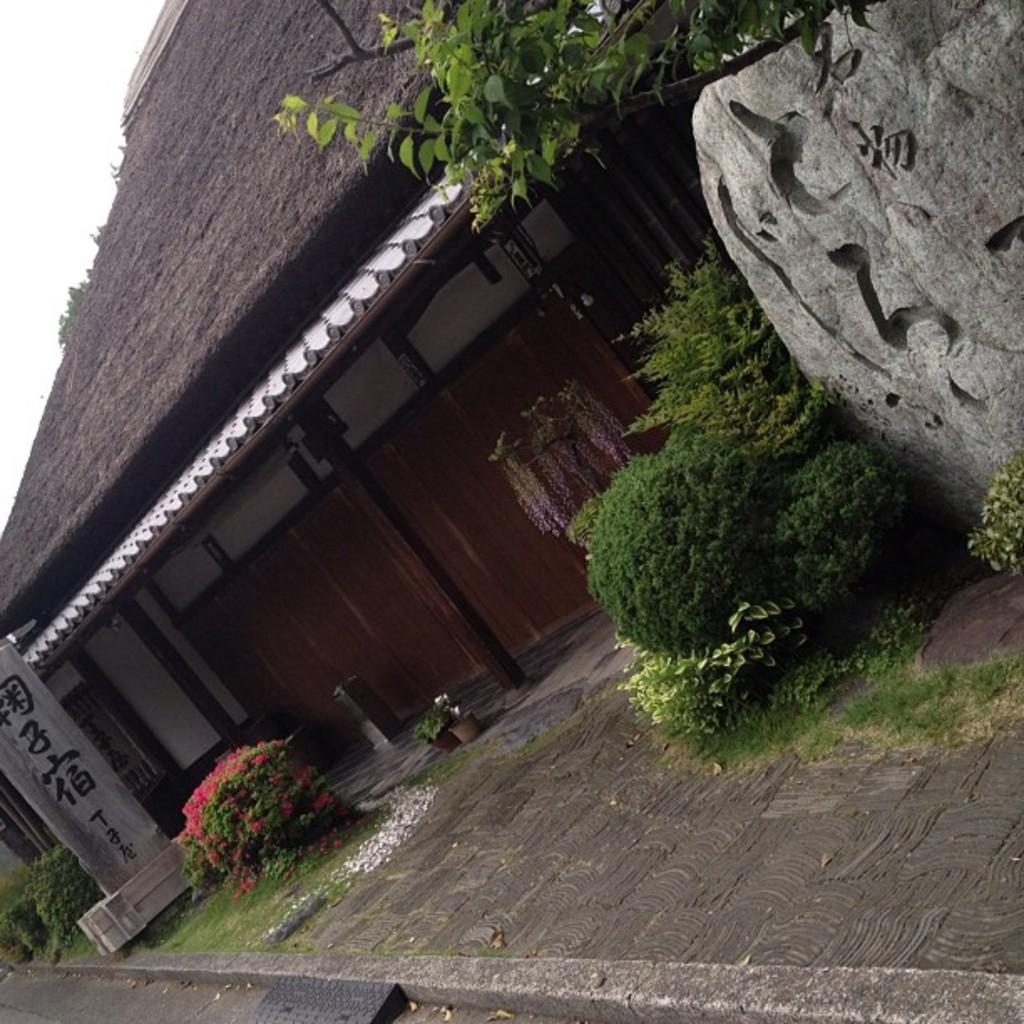What type of structure is visible in the image? There is a building in the image. What natural elements can be seen in the image? There are rocks, laid stones, house plants, and bushes in the image. What is visible in the background of the image? The sky is visible in the background of the image. How much sugar is present in the image? There is no sugar present in the image, as it features a building, rocks, laid stones, house plants, bushes, and the sky. 